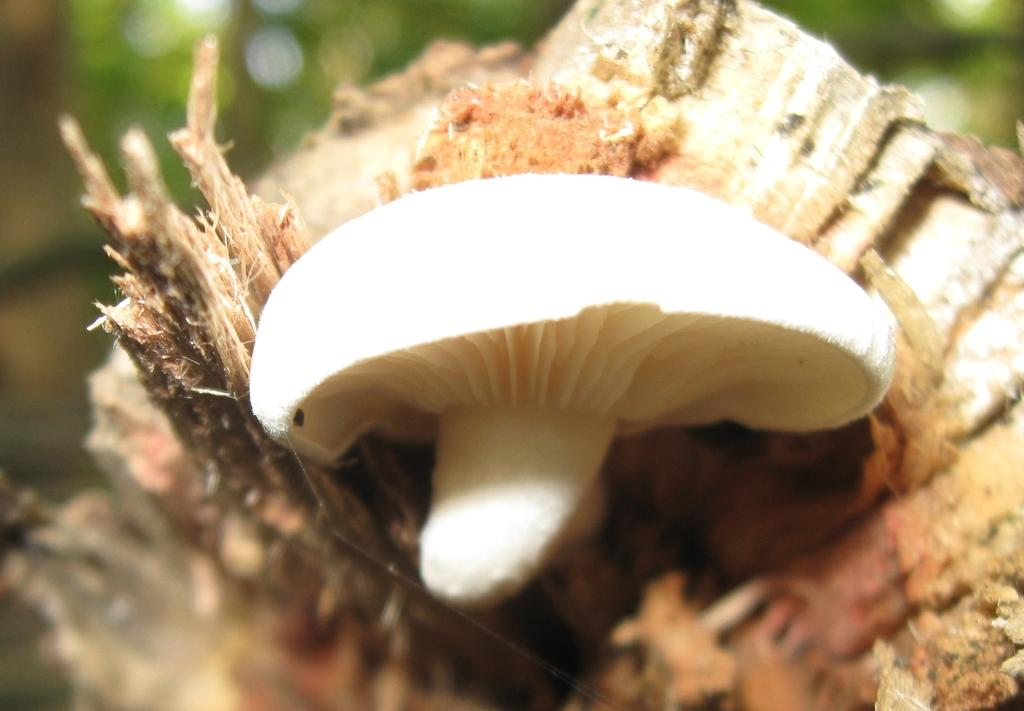What is the main subject of the image? The main subject of the image is a mushroom. Where is the mushroom located? The mushroom is on a tree trunk. What type of iron is being used to control the pest infestation in the image? There is no iron or pest infestation present in the image; it features a mushroom on a tree trunk. How many cents can be seen on the mushroom in the image? There are no cents present on the mushroom in the image. 